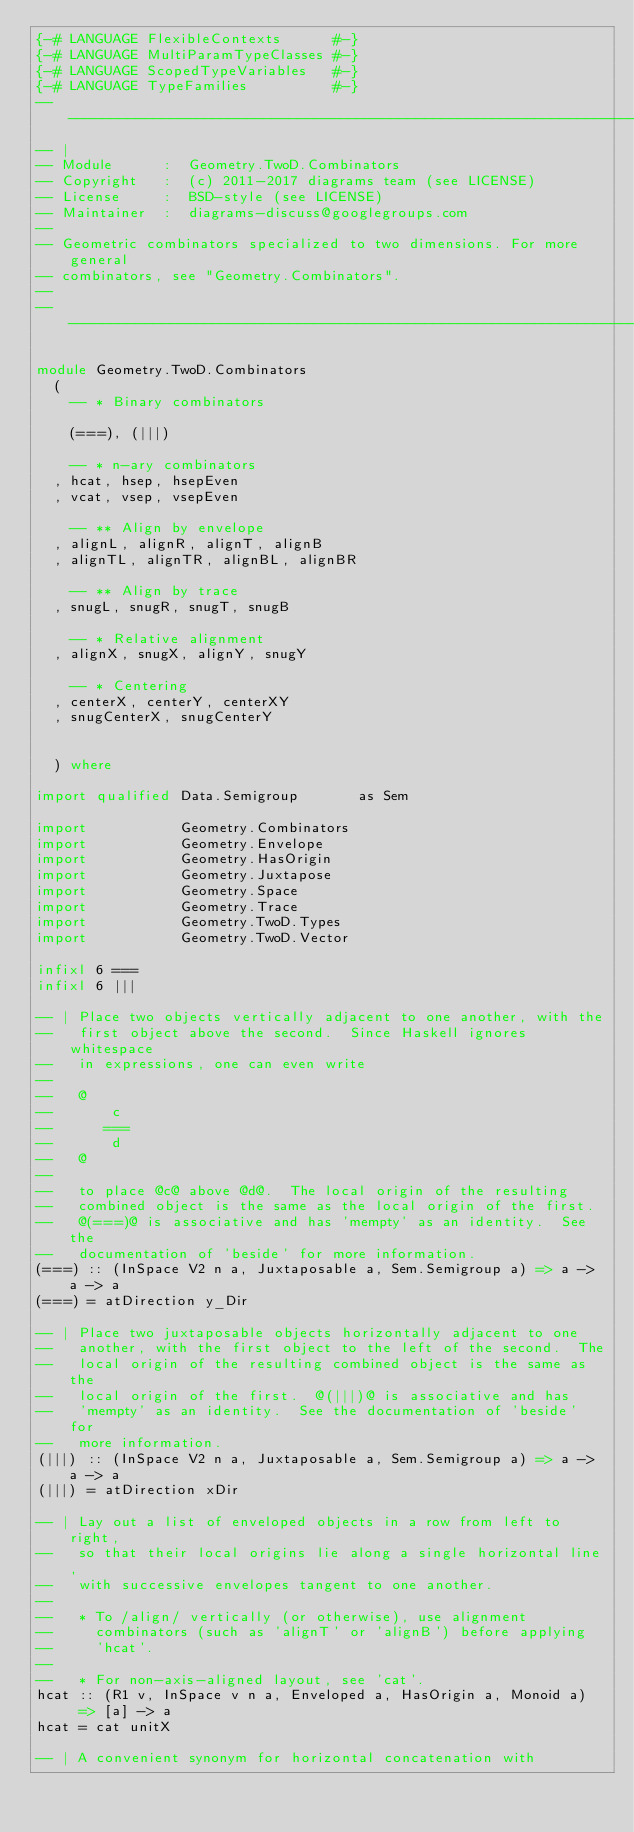Convert code to text. <code><loc_0><loc_0><loc_500><loc_500><_Haskell_>{-# LANGUAGE FlexibleContexts      #-}
{-# LANGUAGE MultiParamTypeClasses #-}
{-# LANGUAGE ScopedTypeVariables   #-}
{-# LANGUAGE TypeFamilies          #-}
-----------------------------------------------------------------------------
-- |
-- Module      :  Geometry.TwoD.Combinators
-- Copyright   :  (c) 2011-2017 diagrams team (see LICENSE)
-- License     :  BSD-style (see LICENSE)
-- Maintainer  :  diagrams-discuss@googlegroups.com
--
-- Geometric combinators specialized to two dimensions. For more general
-- combinators, see "Geometry.Combinators".
--
-----------------------------------------------------------------------------

module Geometry.TwoD.Combinators
  (
    -- * Binary combinators

    (===), (|||)

    -- * n-ary combinators
  , hcat, hsep, hsepEven
  , vcat, vsep, vsepEven

    -- ** Align by envelope
  , alignL, alignR, alignT, alignB
  , alignTL, alignTR, alignBL, alignBR

    -- ** Align by trace
  , snugL, snugR, snugT, snugB

    -- * Relative alignment
  , alignX, snugX, alignY, snugY

    -- * Centering
  , centerX, centerY, centerXY
  , snugCenterX, snugCenterY


  ) where

import qualified Data.Semigroup       as Sem

import           Geometry.Combinators
import           Geometry.Envelope
import           Geometry.HasOrigin
import           Geometry.Juxtapose
import           Geometry.Space
import           Geometry.Trace
import           Geometry.TwoD.Types
import           Geometry.TwoD.Vector

infixl 6 ===
infixl 6 |||

-- | Place two objects vertically adjacent to one another, with the
--   first object above the second.  Since Haskell ignores whitespace
--   in expressions, one can even write
--
--   @
--       c
--      ===
--       d
--   @
--
--   to place @c@ above @d@.  The local origin of the resulting
--   combined object is the same as the local origin of the first.
--   @(===)@ is associative and has 'mempty' as an identity.  See the
--   documentation of 'beside' for more information.
(===) :: (InSpace V2 n a, Juxtaposable a, Sem.Semigroup a) => a -> a -> a
(===) = atDirection y_Dir

-- | Place two juxtaposable objects horizontally adjacent to one
--   another, with the first object to the left of the second.  The
--   local origin of the resulting combined object is the same as the
--   local origin of the first.  @(|||)@ is associative and has
--   'mempty' as an identity.  See the documentation of 'beside' for
--   more information.
(|||) :: (InSpace V2 n a, Juxtaposable a, Sem.Semigroup a) => a -> a -> a
(|||) = atDirection xDir

-- | Lay out a list of enveloped objects in a row from left to right,
--   so that their local origins lie along a single horizontal line,
--   with successive envelopes tangent to one another.
--
--   * To /align/ vertically (or otherwise), use alignment
--     combinators (such as 'alignT' or 'alignB') before applying
--     'hcat'.
--
--   * For non-axis-aligned layout, see 'cat'.
hcat :: (R1 v, InSpace v n a, Enveloped a, HasOrigin a, Monoid a)
     => [a] -> a
hcat = cat unitX

-- | A convenient synonym for horizontal concatenation with</code> 